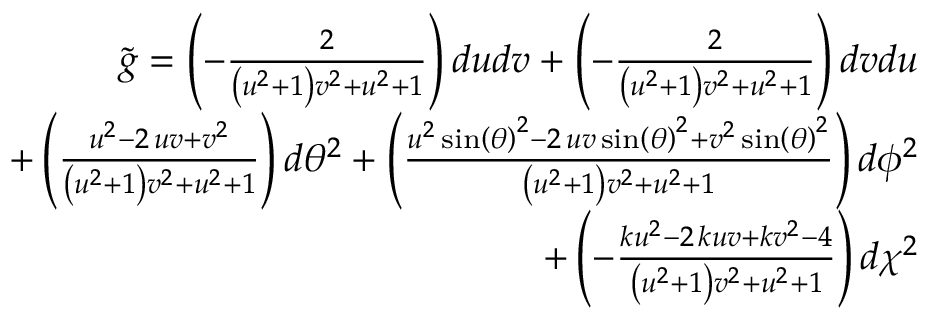Convert formula to latex. <formula><loc_0><loc_0><loc_500><loc_500>\begin{array} { r } { \tilde { g } = \left ( - \frac { 2 } { { \left ( u ^ { 2 } + 1 \right ) } v ^ { 2 } + u ^ { 2 } + 1 } \right ) d u d v + \left ( - \frac { 2 } { { \left ( u ^ { 2 } + 1 \right ) } v ^ { 2 } + u ^ { 2 } + 1 } \right ) d v d u } \\ { + \left ( \frac { u ^ { 2 } - 2 \, u v + v ^ { 2 } } { { \left ( u ^ { 2 } + 1 \right ) } v ^ { 2 } + u ^ { 2 } + 1 } \right ) d \theta ^ { 2 } + \left ( \frac { u ^ { 2 } \sin \left ( { \theta } \right ) ^ { 2 } - 2 \, u v \sin \left ( { \theta } \right ) ^ { 2 } + v ^ { 2 } \sin \left ( { \theta } \right ) ^ { 2 } } { { \left ( u ^ { 2 } + 1 \right ) } v ^ { 2 } + u ^ { 2 } + 1 } \right ) d \phi ^ { 2 } } \\ { + \left ( - \frac { k u ^ { 2 } - 2 \, k u v + k v ^ { 2 } - 4 } { { \left ( u ^ { 2 } + 1 \right ) } v ^ { 2 } + u ^ { 2 } + 1 } \right ) d \chi ^ { 2 } } \end{array}</formula> 